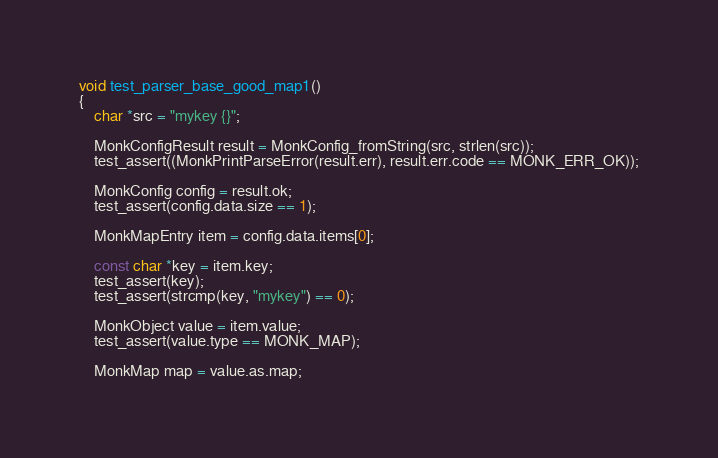Convert code to text. <code><loc_0><loc_0><loc_500><loc_500><_C_>void test_parser_base_good_map1()
{
    char *src = "mykey {}";

    MonkConfigResult result = MonkConfig_fromString(src, strlen(src));
    test_assert((MonkPrintParseError(result.err), result.err.code == MONK_ERR_OK));

    MonkConfig config = result.ok;
    test_assert(config.data.size == 1);

    MonkMapEntry item = config.data.items[0];

    const char *key = item.key;
    test_assert(key);
    test_assert(strcmp(key, "mykey") == 0);

    MonkObject value = item.value;
    test_assert(value.type == MONK_MAP);

    MonkMap map = value.as.map;</code> 